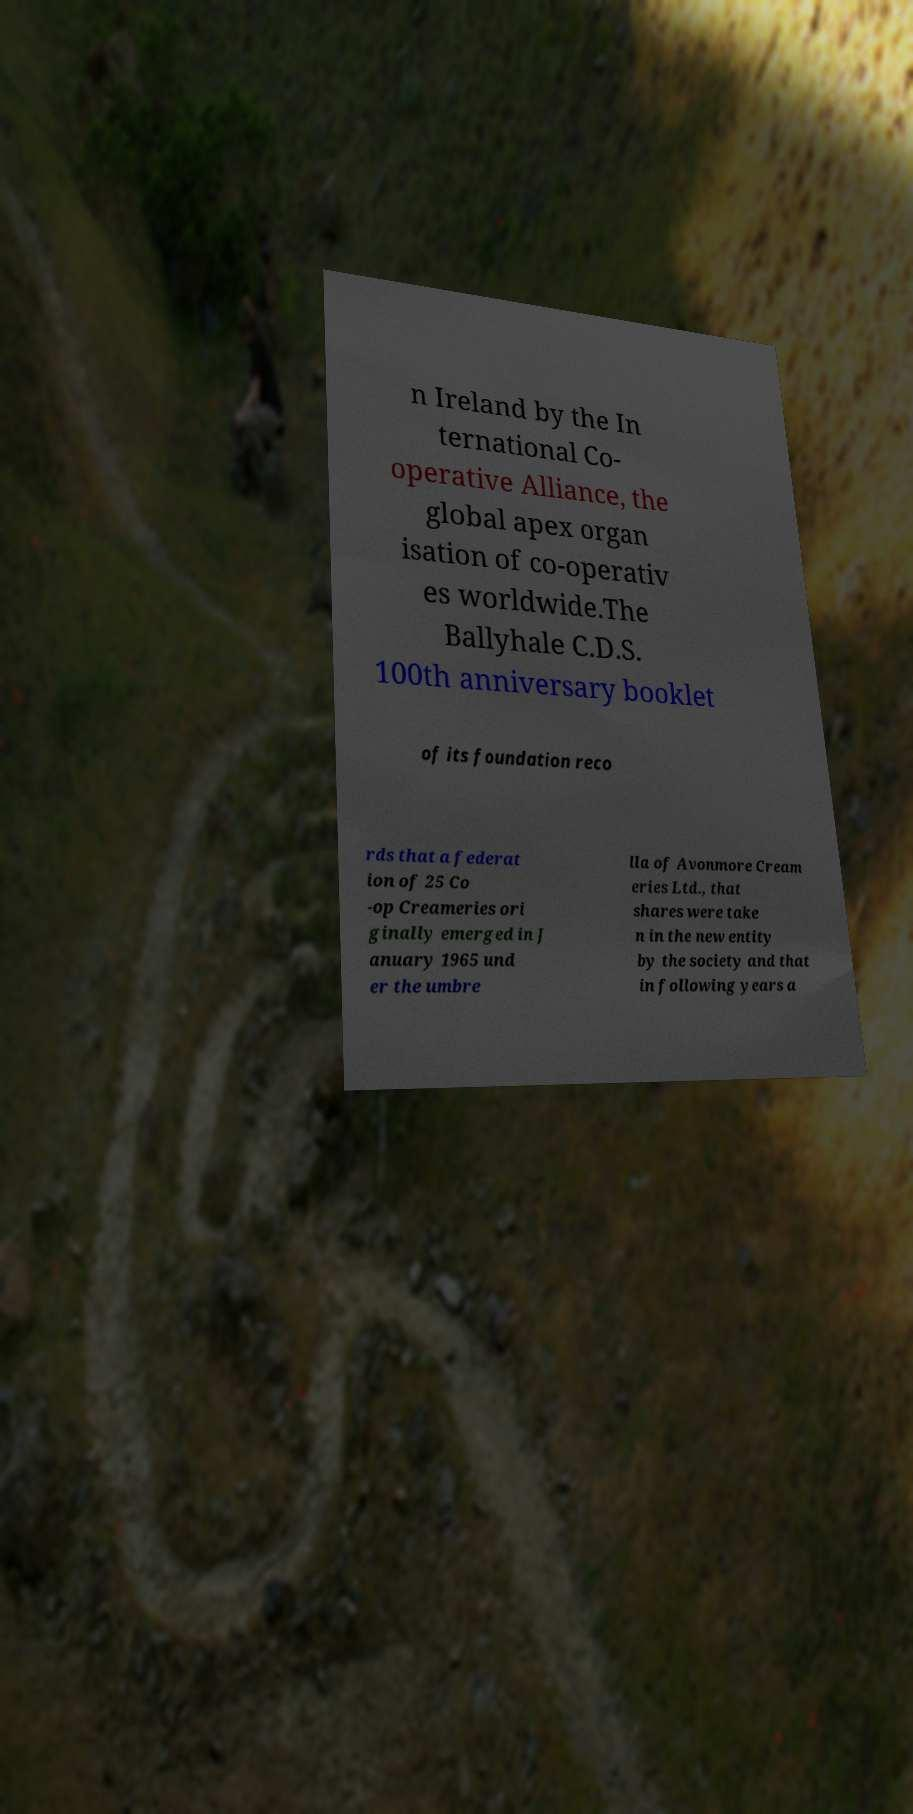Can you read and provide the text displayed in the image?This photo seems to have some interesting text. Can you extract and type it out for me? n Ireland by the In ternational Co- operative Alliance, the global apex organ isation of co-operativ es worldwide.The Ballyhale C.D.S. 100th anniversary booklet of its foundation reco rds that a federat ion of 25 Co -op Creameries ori ginally emerged in J anuary 1965 und er the umbre lla of Avonmore Cream eries Ltd., that shares were take n in the new entity by the society and that in following years a 